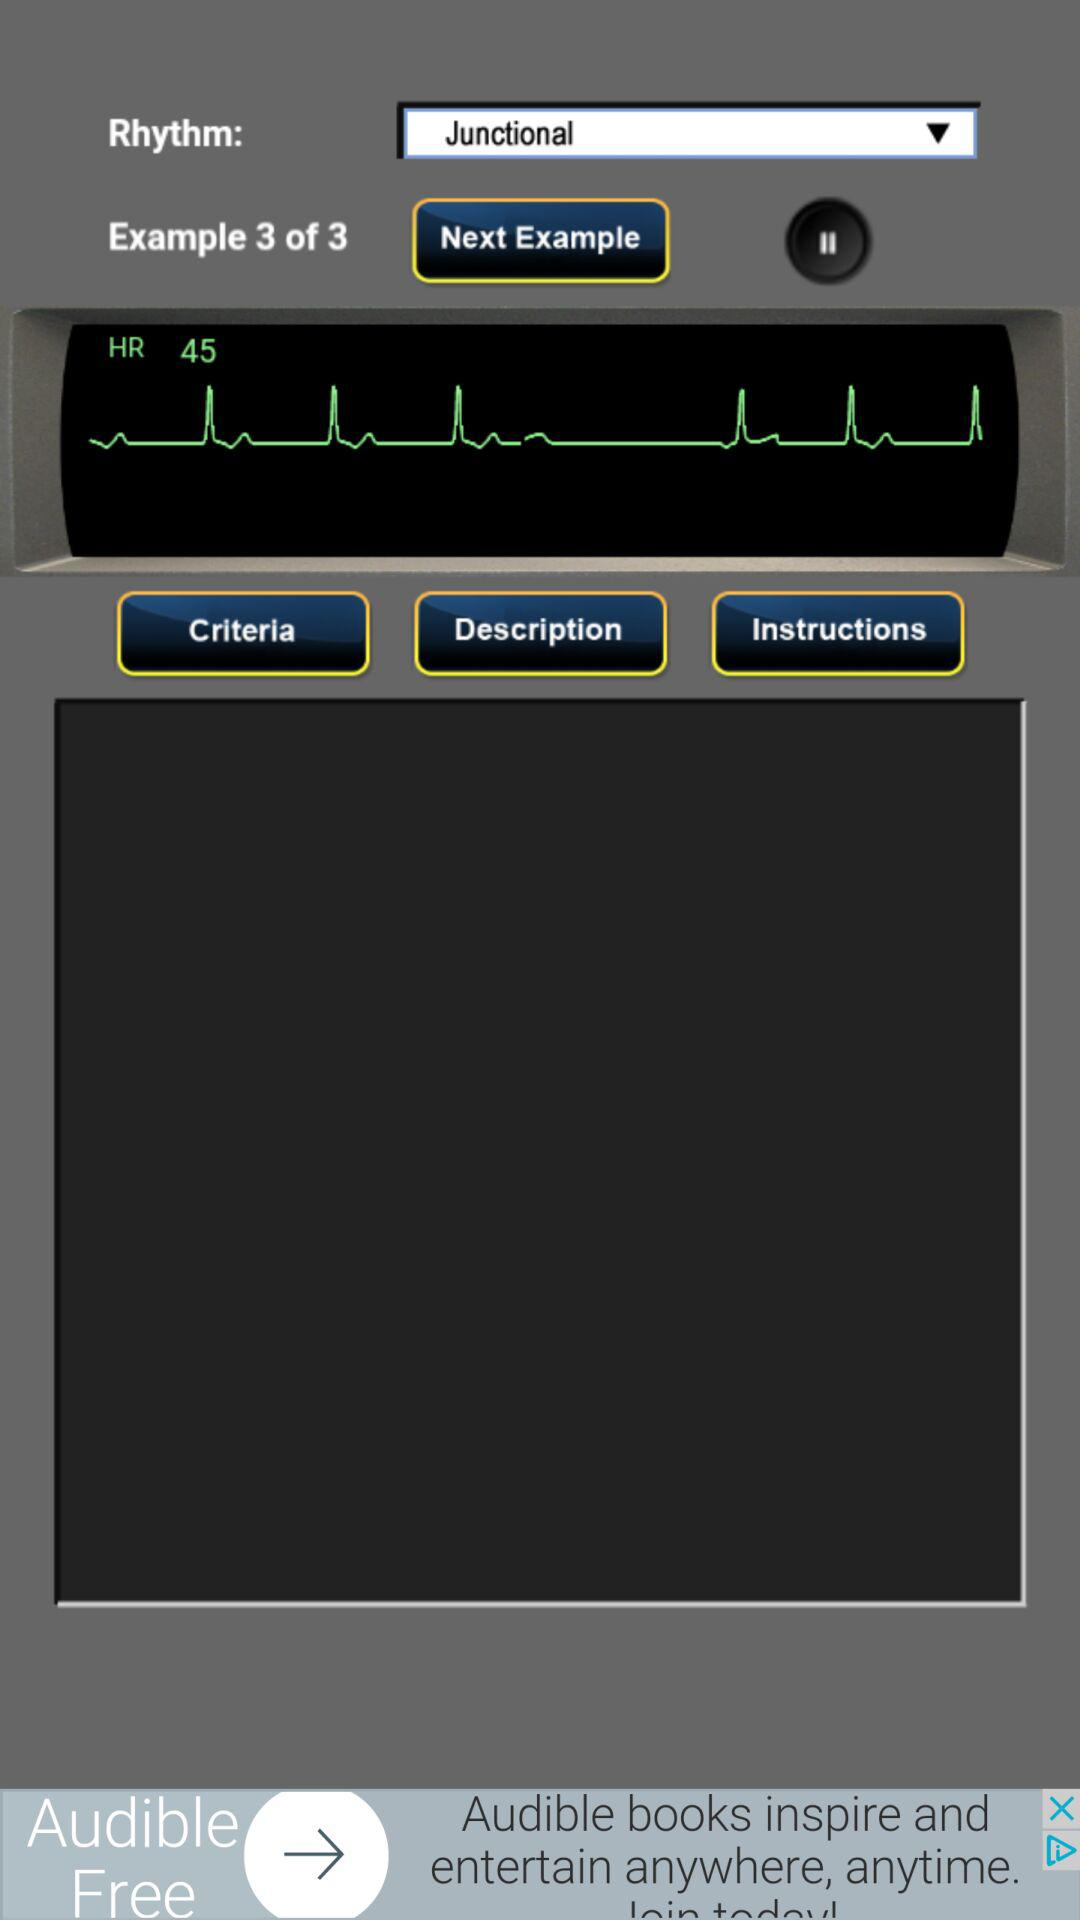How many examples are there in total?
Answer the question using a single word or phrase. 3 